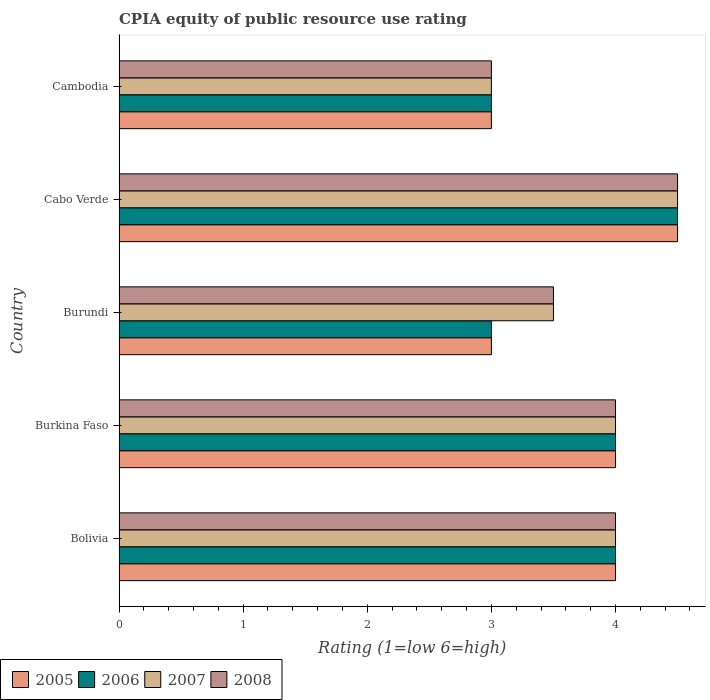How many different coloured bars are there?
Keep it short and to the point. 4. Are the number of bars on each tick of the Y-axis equal?
Keep it short and to the point. Yes. How many bars are there on the 2nd tick from the top?
Ensure brevity in your answer.  4. How many bars are there on the 4th tick from the bottom?
Provide a succinct answer. 4. What is the label of the 3rd group of bars from the top?
Give a very brief answer. Burundi. In how many cases, is the number of bars for a given country not equal to the number of legend labels?
Give a very brief answer. 0. What is the CPIA rating in 2005 in Bolivia?
Keep it short and to the point. 4. In which country was the CPIA rating in 2007 maximum?
Provide a succinct answer. Cabo Verde. In which country was the CPIA rating in 2005 minimum?
Give a very brief answer. Burundi. What is the difference between the CPIA rating in 2008 in Burundi and the CPIA rating in 2006 in Cabo Verde?
Ensure brevity in your answer.  -1. What is the ratio of the CPIA rating in 2008 in Bolivia to that in Burundi?
Your answer should be very brief. 1.14. Is the difference between the CPIA rating in 2007 in Burkina Faso and Burundi greater than the difference between the CPIA rating in 2006 in Burkina Faso and Burundi?
Offer a terse response. No. Is the sum of the CPIA rating in 2005 in Burundi and Cabo Verde greater than the maximum CPIA rating in 2008 across all countries?
Make the answer very short. Yes. What does the 1st bar from the bottom in Bolivia represents?
Offer a terse response. 2005. How many bars are there?
Ensure brevity in your answer.  20. How many countries are there in the graph?
Your response must be concise. 5. Are the values on the major ticks of X-axis written in scientific E-notation?
Offer a very short reply. No. Does the graph contain grids?
Keep it short and to the point. No. Where does the legend appear in the graph?
Provide a succinct answer. Bottom left. How many legend labels are there?
Offer a terse response. 4. What is the title of the graph?
Make the answer very short. CPIA equity of public resource use rating. What is the label or title of the X-axis?
Make the answer very short. Rating (1=low 6=high). What is the label or title of the Y-axis?
Your answer should be compact. Country. What is the Rating (1=low 6=high) of 2005 in Bolivia?
Ensure brevity in your answer.  4. What is the Rating (1=low 6=high) of 2006 in Bolivia?
Offer a very short reply. 4. What is the Rating (1=low 6=high) of 2007 in Bolivia?
Your answer should be very brief. 4. What is the Rating (1=low 6=high) of 2008 in Burkina Faso?
Ensure brevity in your answer.  4. What is the Rating (1=low 6=high) in 2006 in Burundi?
Ensure brevity in your answer.  3. What is the Rating (1=low 6=high) in 2008 in Burundi?
Give a very brief answer. 3.5. What is the Rating (1=low 6=high) of 2005 in Cabo Verde?
Give a very brief answer. 4.5. What is the Rating (1=low 6=high) in 2006 in Cabo Verde?
Ensure brevity in your answer.  4.5. What is the Rating (1=low 6=high) of 2007 in Cabo Verde?
Give a very brief answer. 4.5. What is the Rating (1=low 6=high) in 2008 in Cabo Verde?
Give a very brief answer. 4.5. What is the Rating (1=low 6=high) of 2005 in Cambodia?
Provide a succinct answer. 3. What is the Rating (1=low 6=high) in 2006 in Cambodia?
Offer a very short reply. 3. Across all countries, what is the maximum Rating (1=low 6=high) of 2006?
Ensure brevity in your answer.  4.5. Across all countries, what is the maximum Rating (1=low 6=high) of 2008?
Give a very brief answer. 4.5. Across all countries, what is the minimum Rating (1=low 6=high) in 2005?
Provide a succinct answer. 3. Across all countries, what is the minimum Rating (1=low 6=high) in 2008?
Offer a terse response. 3. What is the difference between the Rating (1=low 6=high) of 2005 in Bolivia and that in Burkina Faso?
Make the answer very short. 0. What is the difference between the Rating (1=low 6=high) of 2006 in Bolivia and that in Burkina Faso?
Keep it short and to the point. 0. What is the difference between the Rating (1=low 6=high) in 2007 in Bolivia and that in Burkina Faso?
Keep it short and to the point. 0. What is the difference between the Rating (1=low 6=high) in 2005 in Bolivia and that in Burundi?
Your answer should be compact. 1. What is the difference between the Rating (1=low 6=high) in 2006 in Bolivia and that in Burundi?
Offer a terse response. 1. What is the difference between the Rating (1=low 6=high) in 2007 in Bolivia and that in Cabo Verde?
Your response must be concise. -0.5. What is the difference between the Rating (1=low 6=high) of 2008 in Bolivia and that in Cabo Verde?
Offer a terse response. -0.5. What is the difference between the Rating (1=low 6=high) of 2006 in Burkina Faso and that in Burundi?
Provide a short and direct response. 1. What is the difference between the Rating (1=low 6=high) of 2008 in Burkina Faso and that in Burundi?
Give a very brief answer. 0.5. What is the difference between the Rating (1=low 6=high) of 2005 in Burundi and that in Cambodia?
Provide a succinct answer. 0. What is the difference between the Rating (1=low 6=high) of 2007 in Burundi and that in Cambodia?
Offer a very short reply. 0.5. What is the difference between the Rating (1=low 6=high) of 2008 in Burundi and that in Cambodia?
Keep it short and to the point. 0.5. What is the difference between the Rating (1=low 6=high) of 2006 in Cabo Verde and that in Cambodia?
Your answer should be compact. 1.5. What is the difference between the Rating (1=low 6=high) of 2008 in Cabo Verde and that in Cambodia?
Your response must be concise. 1.5. What is the difference between the Rating (1=low 6=high) in 2005 in Bolivia and the Rating (1=low 6=high) in 2006 in Burkina Faso?
Your answer should be compact. 0. What is the difference between the Rating (1=low 6=high) of 2006 in Bolivia and the Rating (1=low 6=high) of 2008 in Burkina Faso?
Make the answer very short. 0. What is the difference between the Rating (1=low 6=high) of 2007 in Bolivia and the Rating (1=low 6=high) of 2008 in Burkina Faso?
Provide a succinct answer. 0. What is the difference between the Rating (1=low 6=high) of 2005 in Bolivia and the Rating (1=low 6=high) of 2007 in Burundi?
Give a very brief answer. 0.5. What is the difference between the Rating (1=low 6=high) of 2006 in Bolivia and the Rating (1=low 6=high) of 2007 in Burundi?
Provide a short and direct response. 0.5. What is the difference between the Rating (1=low 6=high) in 2006 in Bolivia and the Rating (1=low 6=high) in 2008 in Burundi?
Make the answer very short. 0.5. What is the difference between the Rating (1=low 6=high) of 2005 in Bolivia and the Rating (1=low 6=high) of 2006 in Cabo Verde?
Keep it short and to the point. -0.5. What is the difference between the Rating (1=low 6=high) in 2005 in Bolivia and the Rating (1=low 6=high) in 2007 in Cabo Verde?
Ensure brevity in your answer.  -0.5. What is the difference between the Rating (1=low 6=high) in 2006 in Bolivia and the Rating (1=low 6=high) in 2007 in Cabo Verde?
Provide a succinct answer. -0.5. What is the difference between the Rating (1=low 6=high) in 2006 in Bolivia and the Rating (1=low 6=high) in 2008 in Cabo Verde?
Give a very brief answer. -0.5. What is the difference between the Rating (1=low 6=high) in 2007 in Bolivia and the Rating (1=low 6=high) in 2008 in Cabo Verde?
Your answer should be compact. -0.5. What is the difference between the Rating (1=low 6=high) of 2005 in Bolivia and the Rating (1=low 6=high) of 2006 in Cambodia?
Provide a succinct answer. 1. What is the difference between the Rating (1=low 6=high) of 2006 in Bolivia and the Rating (1=low 6=high) of 2008 in Cambodia?
Offer a terse response. 1. What is the difference between the Rating (1=low 6=high) of 2005 in Burkina Faso and the Rating (1=low 6=high) of 2006 in Burundi?
Offer a terse response. 1. What is the difference between the Rating (1=low 6=high) of 2006 in Burkina Faso and the Rating (1=low 6=high) of 2008 in Burundi?
Provide a succinct answer. 0.5. What is the difference between the Rating (1=low 6=high) of 2005 in Burkina Faso and the Rating (1=low 6=high) of 2006 in Cabo Verde?
Make the answer very short. -0.5. What is the difference between the Rating (1=low 6=high) in 2005 in Burkina Faso and the Rating (1=low 6=high) in 2008 in Cabo Verde?
Ensure brevity in your answer.  -0.5. What is the difference between the Rating (1=low 6=high) of 2006 in Burkina Faso and the Rating (1=low 6=high) of 2008 in Cabo Verde?
Offer a very short reply. -0.5. What is the difference between the Rating (1=low 6=high) in 2007 in Burkina Faso and the Rating (1=low 6=high) in 2008 in Cabo Verde?
Give a very brief answer. -0.5. What is the difference between the Rating (1=low 6=high) in 2005 in Burkina Faso and the Rating (1=low 6=high) in 2008 in Cambodia?
Provide a short and direct response. 1. What is the difference between the Rating (1=low 6=high) in 2006 in Burkina Faso and the Rating (1=low 6=high) in 2007 in Cambodia?
Provide a succinct answer. 1. What is the difference between the Rating (1=low 6=high) of 2006 in Burkina Faso and the Rating (1=low 6=high) of 2008 in Cambodia?
Your answer should be compact. 1. What is the difference between the Rating (1=low 6=high) of 2007 in Burkina Faso and the Rating (1=low 6=high) of 2008 in Cambodia?
Your response must be concise. 1. What is the difference between the Rating (1=low 6=high) in 2005 in Burundi and the Rating (1=low 6=high) in 2006 in Cabo Verde?
Offer a terse response. -1.5. What is the difference between the Rating (1=low 6=high) of 2007 in Burundi and the Rating (1=low 6=high) of 2008 in Cabo Verde?
Provide a succinct answer. -1. What is the difference between the Rating (1=low 6=high) of 2005 in Burundi and the Rating (1=low 6=high) of 2006 in Cambodia?
Your answer should be compact. 0. What is the difference between the Rating (1=low 6=high) in 2005 in Burundi and the Rating (1=low 6=high) in 2007 in Cambodia?
Your response must be concise. 0. What is the difference between the Rating (1=low 6=high) in 2005 in Burundi and the Rating (1=low 6=high) in 2008 in Cambodia?
Offer a terse response. 0. What is the difference between the Rating (1=low 6=high) of 2006 in Burundi and the Rating (1=low 6=high) of 2007 in Cambodia?
Provide a succinct answer. 0. What is the difference between the Rating (1=low 6=high) in 2006 in Burundi and the Rating (1=low 6=high) in 2008 in Cambodia?
Give a very brief answer. 0. What is the difference between the Rating (1=low 6=high) in 2007 in Burundi and the Rating (1=low 6=high) in 2008 in Cambodia?
Offer a very short reply. 0.5. What is the difference between the Rating (1=low 6=high) in 2005 in Cabo Verde and the Rating (1=low 6=high) in 2006 in Cambodia?
Keep it short and to the point. 1.5. What is the difference between the Rating (1=low 6=high) of 2005 in Cabo Verde and the Rating (1=low 6=high) of 2007 in Cambodia?
Provide a succinct answer. 1.5. What is the difference between the Rating (1=low 6=high) in 2006 in Cabo Verde and the Rating (1=low 6=high) in 2007 in Cambodia?
Ensure brevity in your answer.  1.5. What is the average Rating (1=low 6=high) in 2005 per country?
Ensure brevity in your answer.  3.7. What is the average Rating (1=low 6=high) of 2006 per country?
Your response must be concise. 3.7. What is the average Rating (1=low 6=high) in 2007 per country?
Ensure brevity in your answer.  3.8. What is the difference between the Rating (1=low 6=high) in 2005 and Rating (1=low 6=high) in 2006 in Bolivia?
Give a very brief answer. 0. What is the difference between the Rating (1=low 6=high) of 2005 and Rating (1=low 6=high) of 2007 in Burkina Faso?
Your answer should be very brief. 0. What is the difference between the Rating (1=low 6=high) in 2006 and Rating (1=low 6=high) in 2008 in Burkina Faso?
Make the answer very short. 0. What is the difference between the Rating (1=low 6=high) in 2007 and Rating (1=low 6=high) in 2008 in Burkina Faso?
Make the answer very short. 0. What is the difference between the Rating (1=low 6=high) in 2006 and Rating (1=low 6=high) in 2007 in Burundi?
Your response must be concise. -0.5. What is the difference between the Rating (1=low 6=high) of 2007 and Rating (1=low 6=high) of 2008 in Burundi?
Provide a short and direct response. 0. What is the difference between the Rating (1=low 6=high) of 2005 and Rating (1=low 6=high) of 2006 in Cabo Verde?
Give a very brief answer. 0. What is the difference between the Rating (1=low 6=high) in 2006 and Rating (1=low 6=high) in 2007 in Cabo Verde?
Provide a short and direct response. 0. What is the difference between the Rating (1=low 6=high) in 2007 and Rating (1=low 6=high) in 2008 in Cabo Verde?
Your response must be concise. 0. What is the difference between the Rating (1=low 6=high) of 2005 and Rating (1=low 6=high) of 2007 in Cambodia?
Keep it short and to the point. 0. What is the difference between the Rating (1=low 6=high) of 2005 and Rating (1=low 6=high) of 2008 in Cambodia?
Your answer should be compact. 0. What is the difference between the Rating (1=low 6=high) of 2006 and Rating (1=low 6=high) of 2008 in Cambodia?
Make the answer very short. 0. What is the difference between the Rating (1=low 6=high) of 2007 and Rating (1=low 6=high) of 2008 in Cambodia?
Offer a very short reply. 0. What is the ratio of the Rating (1=low 6=high) in 2006 in Bolivia to that in Burkina Faso?
Ensure brevity in your answer.  1. What is the ratio of the Rating (1=low 6=high) in 2007 in Bolivia to that in Burkina Faso?
Make the answer very short. 1. What is the ratio of the Rating (1=low 6=high) in 2008 in Bolivia to that in Burkina Faso?
Provide a succinct answer. 1. What is the ratio of the Rating (1=low 6=high) of 2006 in Bolivia to that in Cabo Verde?
Provide a short and direct response. 0.89. What is the ratio of the Rating (1=low 6=high) in 2007 in Bolivia to that in Cabo Verde?
Provide a short and direct response. 0.89. What is the ratio of the Rating (1=low 6=high) of 2006 in Bolivia to that in Cambodia?
Provide a short and direct response. 1.33. What is the ratio of the Rating (1=low 6=high) in 2007 in Bolivia to that in Cambodia?
Your answer should be very brief. 1.33. What is the ratio of the Rating (1=low 6=high) of 2005 in Burkina Faso to that in Burundi?
Your answer should be compact. 1.33. What is the ratio of the Rating (1=low 6=high) of 2007 in Burkina Faso to that in Burundi?
Your answer should be compact. 1.14. What is the ratio of the Rating (1=low 6=high) in 2005 in Burkina Faso to that in Cabo Verde?
Your answer should be very brief. 0.89. What is the ratio of the Rating (1=low 6=high) of 2006 in Burkina Faso to that in Cabo Verde?
Offer a terse response. 0.89. What is the ratio of the Rating (1=low 6=high) of 2008 in Burkina Faso to that in Cabo Verde?
Make the answer very short. 0.89. What is the ratio of the Rating (1=low 6=high) of 2005 in Burkina Faso to that in Cambodia?
Keep it short and to the point. 1.33. What is the ratio of the Rating (1=low 6=high) of 2008 in Burkina Faso to that in Cambodia?
Offer a terse response. 1.33. What is the ratio of the Rating (1=low 6=high) of 2006 in Burundi to that in Cabo Verde?
Keep it short and to the point. 0.67. What is the ratio of the Rating (1=low 6=high) of 2008 in Burundi to that in Cabo Verde?
Make the answer very short. 0.78. What is the ratio of the Rating (1=low 6=high) of 2005 in Burundi to that in Cambodia?
Offer a terse response. 1. What is the ratio of the Rating (1=low 6=high) of 2006 in Burundi to that in Cambodia?
Keep it short and to the point. 1. What is the ratio of the Rating (1=low 6=high) of 2007 in Burundi to that in Cambodia?
Give a very brief answer. 1.17. What is the ratio of the Rating (1=low 6=high) in 2007 in Cabo Verde to that in Cambodia?
Keep it short and to the point. 1.5. What is the difference between the highest and the second highest Rating (1=low 6=high) of 2006?
Offer a very short reply. 0.5. What is the difference between the highest and the lowest Rating (1=low 6=high) of 2005?
Your answer should be very brief. 1.5. What is the difference between the highest and the lowest Rating (1=low 6=high) in 2006?
Offer a terse response. 1.5. What is the difference between the highest and the lowest Rating (1=low 6=high) in 2008?
Your answer should be very brief. 1.5. 